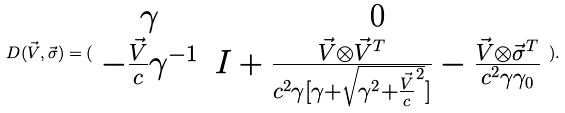<formula> <loc_0><loc_0><loc_500><loc_500>D ( \vec { V } , \vec { \sigma } ) = ( \begin{array} { c c } \gamma & 0 \\ - \frac { \vec { V } } { c } \gamma ^ { - 1 } & I + \frac { \vec { V } \otimes \vec { V } ^ { T } } { c ^ { 2 } \gamma [ \gamma + \sqrt { \gamma ^ { 2 } + \frac { \vec { V } } { c } ^ { 2 } } ] } - \frac { \vec { V } \otimes \vec { \sigma } ^ { T } } { c ^ { 2 } \gamma \gamma _ { 0 } } \end{array} ) .</formula> 